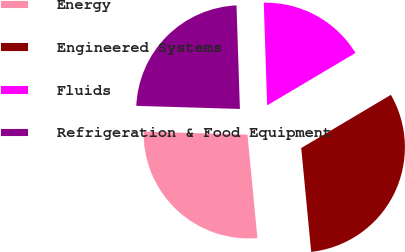Convert chart. <chart><loc_0><loc_0><loc_500><loc_500><pie_chart><fcel>Energy<fcel>Engineered Systems<fcel>Fluids<fcel>Refrigeration & Food Equipment<nl><fcel>27.0%<fcel>32.0%<fcel>17.0%<fcel>24.0%<nl></chart> 